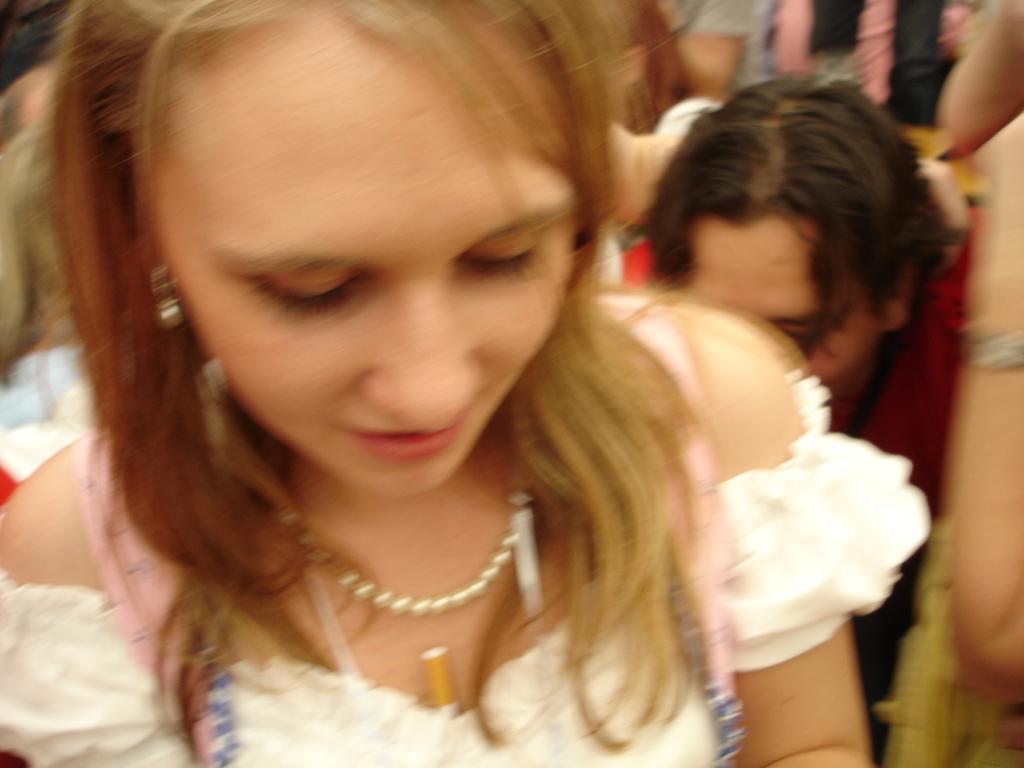In one or two sentences, can you explain what this image depicts? In this image, we can see a woman in a white dress. On the left side of the image, we can see man. In the background, there are people and blur view. 